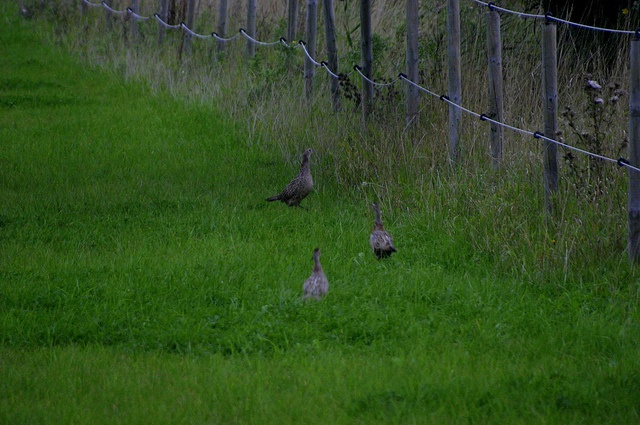Describe the objects in this image and their specific colors. I can see bird in darkgreen and gray tones, bird in darkgreen, black, and gray tones, and bird in darkgreen, gray, and black tones in this image. 